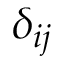Convert formula to latex. <formula><loc_0><loc_0><loc_500><loc_500>\delta _ { i j }</formula> 